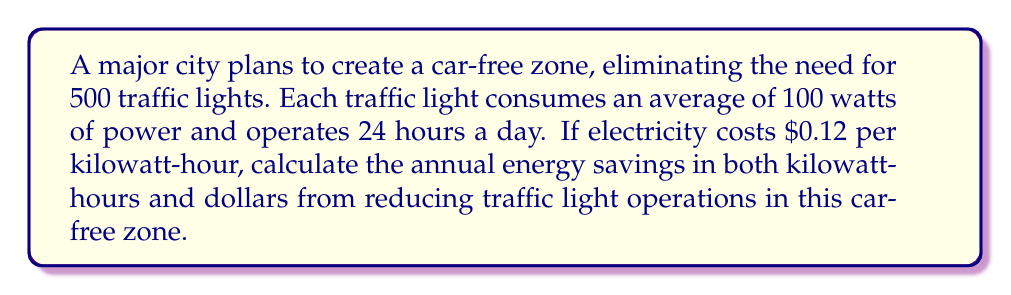Teach me how to tackle this problem. Let's approach this problem step-by-step:

1. Calculate the daily energy consumption of one traffic light:
   $$ \text{Daily consumption} = 100 \text{ watts} \times 24 \text{ hours} = 2400 \text{ watt-hours} = 2.4 \text{ kWh} $$

2. Calculate the annual energy consumption of one traffic light:
   $$ \text{Annual consumption} = 2.4 \text{ kWh} \times 365 \text{ days} = 876 \text{ kWh} $$

3. Calculate the total annual energy savings for all 500 traffic lights:
   $$ \text{Total annual energy savings} = 876 \text{ kWh} \times 500 \text{ lights} = 438,000 \text{ kWh} $$

4. Calculate the annual cost savings:
   $$ \text{Annual cost savings} = 438,000 \text{ kWh} \times \$0.12/\text{kWh} = \$52,560 $$

Therefore, the annual energy savings from reducing traffic light operations in the car-free zone would be 438,000 kWh, which translates to $52,560 in cost savings.
Answer: Annual energy savings: 438,000 kWh
Annual cost savings: $52,560 